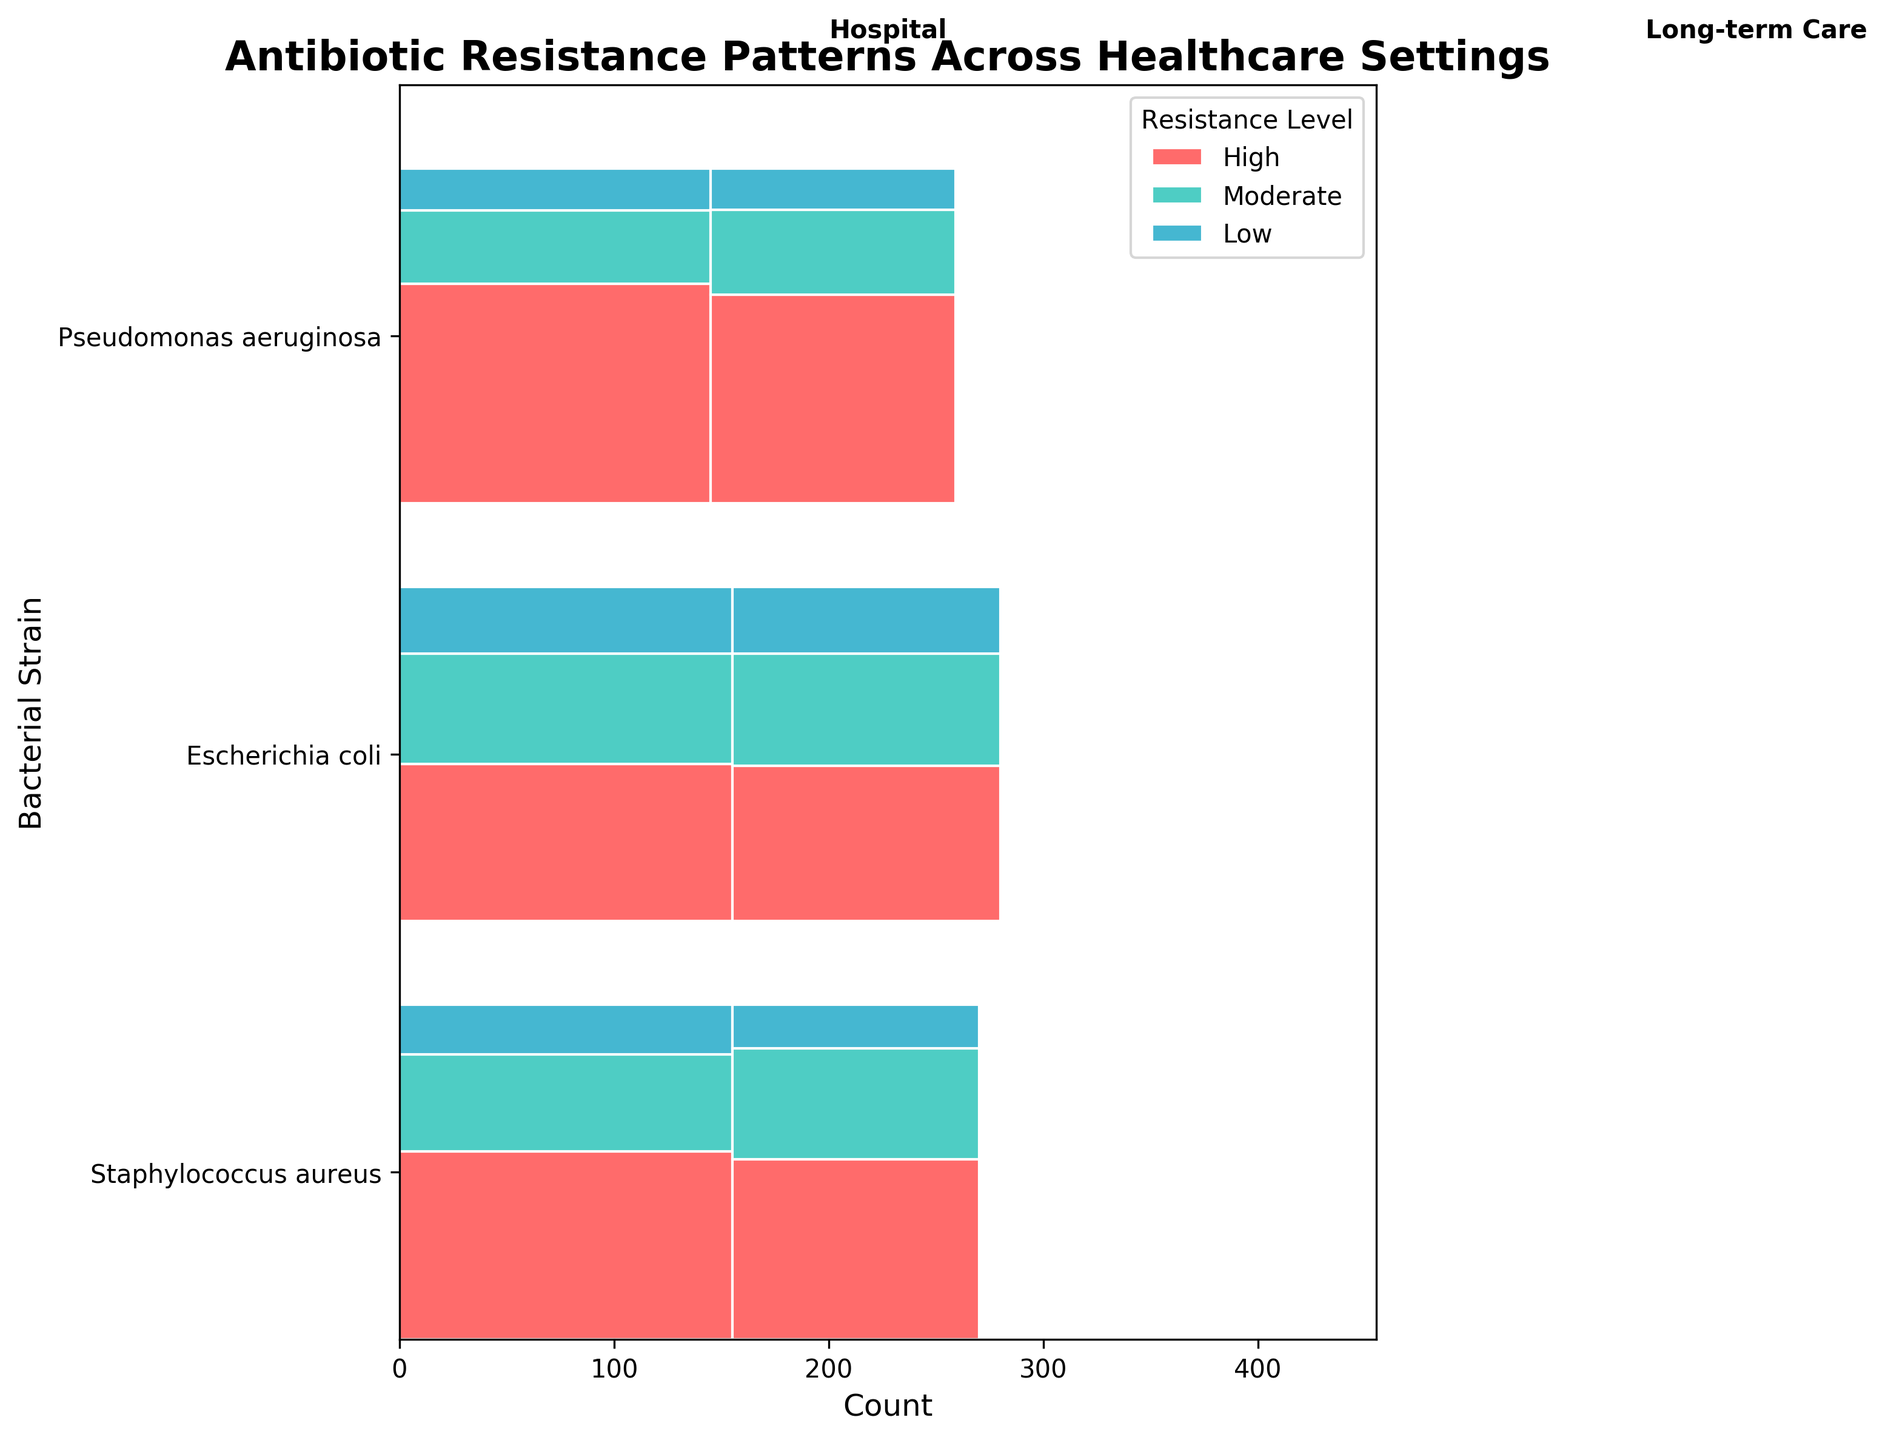What is the title of the mosaic plot? The title is prominently displayed at the top of the plot.
Answer: Antibiotic Resistance Patterns Across Healthcare Settings How many bacterial strains are represented in the mosaic plot? By examining the y-axis of the plot, we can count the number of different bacterial strains listed.
Answer: 3 Which resistance level is represented by the color '#FF6B6B'? The legend in the plot specifies which color corresponds to each resistance level.
Answer: High Which bacterial strain in the hospital setting has the highest count of high resistance? We look at the segments in the hospital setting for each bacterial strain and compare the sizes of the high resistance sections.
Answer: Pseudomonas aeruginosa What is the total count of Escherichia coli in the long-term care setting? By summing the counts of high, moderate, and low resistance levels for Escherichia coli in the long-term care setting, we get the total.
Answer: 125 How does the count of high resistance Staphylococcus aureus compare between hospital and long-term care settings? Analyze the size of the high resistance sections for Staphylococcus aureus in both settings to determine which is larger.
Answer: Hospital has a higher count Which bacterial strain has the least low resistance in the long-term care setting? Compare the sizes of the low resistance sections for each bacterial strain in the long-term care setting.
Answer: Pseudomonas aeruginosa Is the proportion of high resistance Escherichia coli greater in the hospital or long-term care setting? Calculate the proportion of high resistance Escherichia coli in both settings using their respective total counts and compare them.
Answer: Hospital What is the total count of high resistance across all bacterial strains in the hospital setting? Sum the high resistance counts for all bacterial strains in the hospital setting.
Answer: 255 Which healthcare setting generally has higher counts of antibiotic resistance? By comparing the overall widths of the sections for each healthcare setting, we can determine which setting has more counts.
Answer: Hospital 